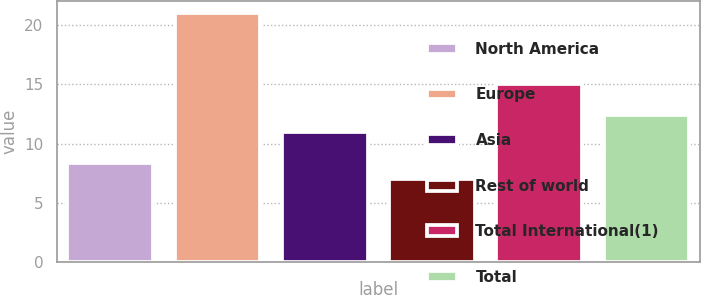<chart> <loc_0><loc_0><loc_500><loc_500><bar_chart><fcel>North America<fcel>Europe<fcel>Asia<fcel>Rest of world<fcel>Total International(1)<fcel>Total<nl><fcel>8.4<fcel>21<fcel>11<fcel>7<fcel>15<fcel>12.4<nl></chart> 